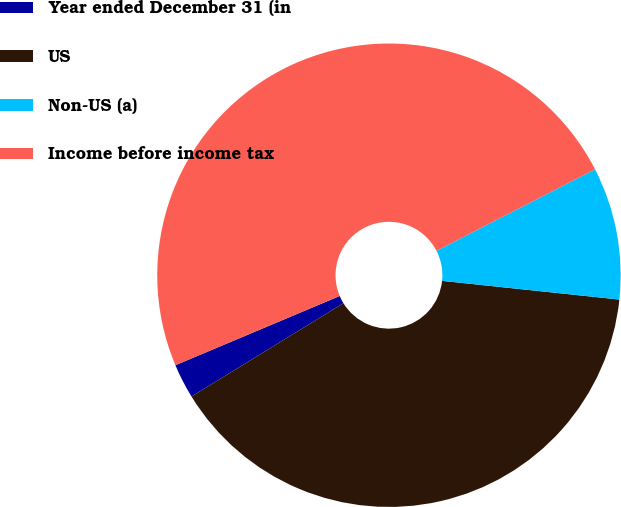Convert chart. <chart><loc_0><loc_0><loc_500><loc_500><pie_chart><fcel>Year ended December 31 (in<fcel>US<fcel>Non-US (a)<fcel>Income before income tax<nl><fcel>2.42%<fcel>39.56%<fcel>9.23%<fcel>48.79%<nl></chart> 